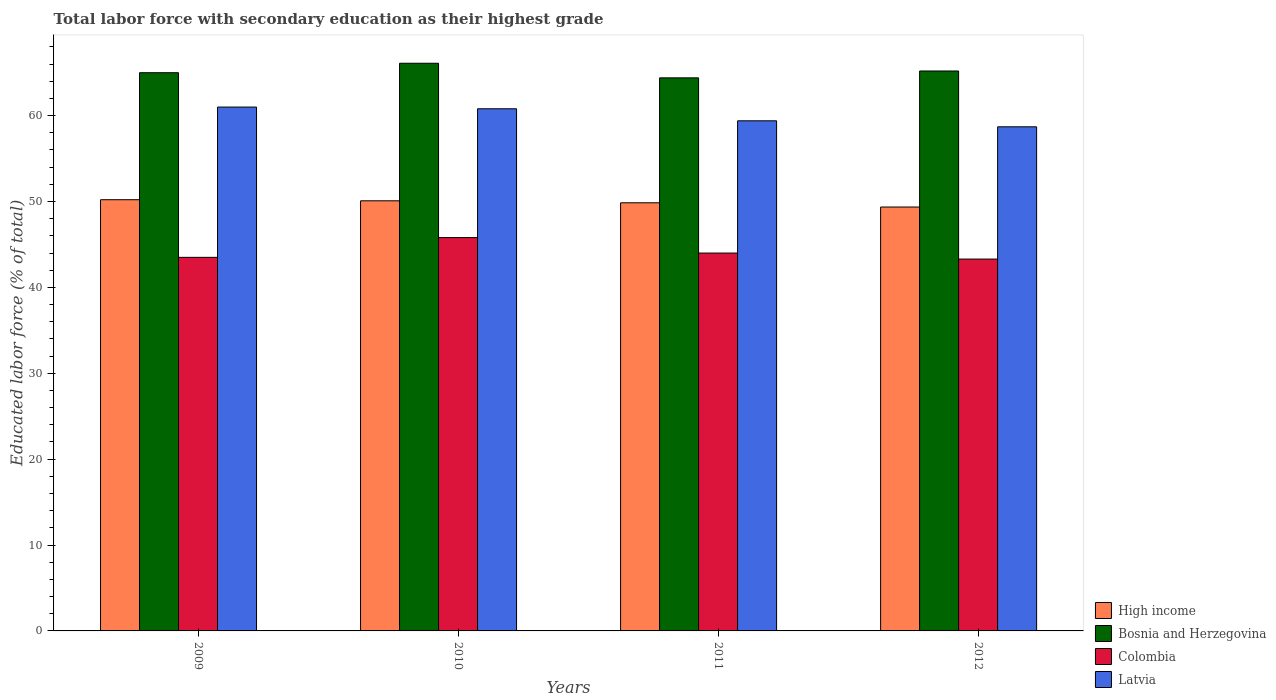How many different coloured bars are there?
Give a very brief answer. 4. How many groups of bars are there?
Your answer should be compact. 4. How many bars are there on the 4th tick from the left?
Provide a succinct answer. 4. How many bars are there on the 1st tick from the right?
Offer a terse response. 4. What is the label of the 1st group of bars from the left?
Keep it short and to the point. 2009. In how many cases, is the number of bars for a given year not equal to the number of legend labels?
Your response must be concise. 0. Across all years, what is the maximum percentage of total labor force with primary education in Colombia?
Make the answer very short. 45.8. Across all years, what is the minimum percentage of total labor force with primary education in High income?
Your answer should be very brief. 49.36. In which year was the percentage of total labor force with primary education in Latvia maximum?
Give a very brief answer. 2009. In which year was the percentage of total labor force with primary education in Latvia minimum?
Provide a succinct answer. 2012. What is the total percentage of total labor force with primary education in High income in the graph?
Give a very brief answer. 199.51. What is the difference between the percentage of total labor force with primary education in Bosnia and Herzegovina in 2009 and that in 2011?
Keep it short and to the point. 0.6. What is the difference between the percentage of total labor force with primary education in Colombia in 2011 and the percentage of total labor force with primary education in Bosnia and Herzegovina in 2009?
Your answer should be compact. -21. What is the average percentage of total labor force with primary education in Latvia per year?
Your response must be concise. 59.98. In the year 2011, what is the difference between the percentage of total labor force with primary education in Latvia and percentage of total labor force with primary education in Bosnia and Herzegovina?
Offer a terse response. -5. In how many years, is the percentage of total labor force with primary education in Bosnia and Herzegovina greater than 48 %?
Your answer should be very brief. 4. What is the ratio of the percentage of total labor force with primary education in Colombia in 2009 to that in 2010?
Your answer should be compact. 0.95. What is the difference between the highest and the second highest percentage of total labor force with primary education in Colombia?
Your answer should be very brief. 1.8. What is the difference between the highest and the lowest percentage of total labor force with primary education in Latvia?
Offer a terse response. 2.3. In how many years, is the percentage of total labor force with primary education in High income greater than the average percentage of total labor force with primary education in High income taken over all years?
Ensure brevity in your answer.  2. What does the 2nd bar from the left in 2009 represents?
Keep it short and to the point. Bosnia and Herzegovina. What does the 1st bar from the right in 2009 represents?
Your answer should be very brief. Latvia. How many bars are there?
Keep it short and to the point. 16. Are all the bars in the graph horizontal?
Your answer should be very brief. No. How many years are there in the graph?
Ensure brevity in your answer.  4. What is the difference between two consecutive major ticks on the Y-axis?
Offer a terse response. 10. Does the graph contain any zero values?
Give a very brief answer. No. Does the graph contain grids?
Your answer should be very brief. No. How many legend labels are there?
Make the answer very short. 4. What is the title of the graph?
Your answer should be very brief. Total labor force with secondary education as their highest grade. Does "Comoros" appear as one of the legend labels in the graph?
Your response must be concise. No. What is the label or title of the Y-axis?
Your answer should be compact. Educated labor force (% of total). What is the Educated labor force (% of total) in High income in 2009?
Your answer should be compact. 50.21. What is the Educated labor force (% of total) of Colombia in 2009?
Give a very brief answer. 43.5. What is the Educated labor force (% of total) of High income in 2010?
Provide a short and direct response. 50.08. What is the Educated labor force (% of total) in Bosnia and Herzegovina in 2010?
Your response must be concise. 66.1. What is the Educated labor force (% of total) in Colombia in 2010?
Your response must be concise. 45.8. What is the Educated labor force (% of total) of Latvia in 2010?
Your response must be concise. 60.8. What is the Educated labor force (% of total) of High income in 2011?
Provide a succinct answer. 49.85. What is the Educated labor force (% of total) in Bosnia and Herzegovina in 2011?
Give a very brief answer. 64.4. What is the Educated labor force (% of total) of Colombia in 2011?
Make the answer very short. 44. What is the Educated labor force (% of total) in Latvia in 2011?
Your response must be concise. 59.4. What is the Educated labor force (% of total) of High income in 2012?
Offer a terse response. 49.36. What is the Educated labor force (% of total) in Bosnia and Herzegovina in 2012?
Your response must be concise. 65.2. What is the Educated labor force (% of total) in Colombia in 2012?
Make the answer very short. 43.3. What is the Educated labor force (% of total) in Latvia in 2012?
Offer a terse response. 58.7. Across all years, what is the maximum Educated labor force (% of total) in High income?
Your answer should be very brief. 50.21. Across all years, what is the maximum Educated labor force (% of total) of Bosnia and Herzegovina?
Your answer should be compact. 66.1. Across all years, what is the maximum Educated labor force (% of total) in Colombia?
Give a very brief answer. 45.8. Across all years, what is the minimum Educated labor force (% of total) in High income?
Provide a short and direct response. 49.36. Across all years, what is the minimum Educated labor force (% of total) of Bosnia and Herzegovina?
Provide a succinct answer. 64.4. Across all years, what is the minimum Educated labor force (% of total) of Colombia?
Your answer should be very brief. 43.3. Across all years, what is the minimum Educated labor force (% of total) of Latvia?
Provide a succinct answer. 58.7. What is the total Educated labor force (% of total) of High income in the graph?
Your response must be concise. 199.51. What is the total Educated labor force (% of total) of Bosnia and Herzegovina in the graph?
Offer a terse response. 260.7. What is the total Educated labor force (% of total) in Colombia in the graph?
Your answer should be compact. 176.6. What is the total Educated labor force (% of total) of Latvia in the graph?
Offer a terse response. 239.9. What is the difference between the Educated labor force (% of total) of High income in 2009 and that in 2010?
Give a very brief answer. 0.13. What is the difference between the Educated labor force (% of total) in Bosnia and Herzegovina in 2009 and that in 2010?
Ensure brevity in your answer.  -1.1. What is the difference between the Educated labor force (% of total) in Latvia in 2009 and that in 2010?
Make the answer very short. 0.2. What is the difference between the Educated labor force (% of total) of High income in 2009 and that in 2011?
Your response must be concise. 0.36. What is the difference between the Educated labor force (% of total) in Colombia in 2009 and that in 2011?
Offer a very short reply. -0.5. What is the difference between the Educated labor force (% of total) of Latvia in 2009 and that in 2011?
Provide a short and direct response. 1.6. What is the difference between the Educated labor force (% of total) of High income in 2009 and that in 2012?
Offer a terse response. 0.85. What is the difference between the Educated labor force (% of total) of Colombia in 2009 and that in 2012?
Your answer should be compact. 0.2. What is the difference between the Educated labor force (% of total) in Latvia in 2009 and that in 2012?
Provide a short and direct response. 2.3. What is the difference between the Educated labor force (% of total) in High income in 2010 and that in 2011?
Give a very brief answer. 0.23. What is the difference between the Educated labor force (% of total) in Bosnia and Herzegovina in 2010 and that in 2011?
Your answer should be very brief. 1.7. What is the difference between the Educated labor force (% of total) in High income in 2010 and that in 2012?
Your answer should be compact. 0.72. What is the difference between the Educated labor force (% of total) of Bosnia and Herzegovina in 2010 and that in 2012?
Provide a succinct answer. 0.9. What is the difference between the Educated labor force (% of total) in Latvia in 2010 and that in 2012?
Offer a terse response. 2.1. What is the difference between the Educated labor force (% of total) of High income in 2011 and that in 2012?
Offer a very short reply. 0.49. What is the difference between the Educated labor force (% of total) in Bosnia and Herzegovina in 2011 and that in 2012?
Make the answer very short. -0.8. What is the difference between the Educated labor force (% of total) in Colombia in 2011 and that in 2012?
Offer a terse response. 0.7. What is the difference between the Educated labor force (% of total) of High income in 2009 and the Educated labor force (% of total) of Bosnia and Herzegovina in 2010?
Your answer should be very brief. -15.89. What is the difference between the Educated labor force (% of total) of High income in 2009 and the Educated labor force (% of total) of Colombia in 2010?
Offer a very short reply. 4.41. What is the difference between the Educated labor force (% of total) in High income in 2009 and the Educated labor force (% of total) in Latvia in 2010?
Offer a terse response. -10.59. What is the difference between the Educated labor force (% of total) in Bosnia and Herzegovina in 2009 and the Educated labor force (% of total) in Colombia in 2010?
Provide a succinct answer. 19.2. What is the difference between the Educated labor force (% of total) of Colombia in 2009 and the Educated labor force (% of total) of Latvia in 2010?
Your answer should be very brief. -17.3. What is the difference between the Educated labor force (% of total) in High income in 2009 and the Educated labor force (% of total) in Bosnia and Herzegovina in 2011?
Give a very brief answer. -14.19. What is the difference between the Educated labor force (% of total) of High income in 2009 and the Educated labor force (% of total) of Colombia in 2011?
Ensure brevity in your answer.  6.21. What is the difference between the Educated labor force (% of total) of High income in 2009 and the Educated labor force (% of total) of Latvia in 2011?
Your answer should be compact. -9.19. What is the difference between the Educated labor force (% of total) of Bosnia and Herzegovina in 2009 and the Educated labor force (% of total) of Colombia in 2011?
Offer a very short reply. 21. What is the difference between the Educated labor force (% of total) of Colombia in 2009 and the Educated labor force (% of total) of Latvia in 2011?
Offer a very short reply. -15.9. What is the difference between the Educated labor force (% of total) in High income in 2009 and the Educated labor force (% of total) in Bosnia and Herzegovina in 2012?
Make the answer very short. -14.99. What is the difference between the Educated labor force (% of total) in High income in 2009 and the Educated labor force (% of total) in Colombia in 2012?
Give a very brief answer. 6.91. What is the difference between the Educated labor force (% of total) in High income in 2009 and the Educated labor force (% of total) in Latvia in 2012?
Offer a very short reply. -8.49. What is the difference between the Educated labor force (% of total) of Bosnia and Herzegovina in 2009 and the Educated labor force (% of total) of Colombia in 2012?
Offer a very short reply. 21.7. What is the difference between the Educated labor force (% of total) in Bosnia and Herzegovina in 2009 and the Educated labor force (% of total) in Latvia in 2012?
Keep it short and to the point. 6.3. What is the difference between the Educated labor force (% of total) in Colombia in 2009 and the Educated labor force (% of total) in Latvia in 2012?
Your response must be concise. -15.2. What is the difference between the Educated labor force (% of total) of High income in 2010 and the Educated labor force (% of total) of Bosnia and Herzegovina in 2011?
Provide a short and direct response. -14.32. What is the difference between the Educated labor force (% of total) in High income in 2010 and the Educated labor force (% of total) in Colombia in 2011?
Offer a terse response. 6.08. What is the difference between the Educated labor force (% of total) in High income in 2010 and the Educated labor force (% of total) in Latvia in 2011?
Your response must be concise. -9.32. What is the difference between the Educated labor force (% of total) in Bosnia and Herzegovina in 2010 and the Educated labor force (% of total) in Colombia in 2011?
Make the answer very short. 22.1. What is the difference between the Educated labor force (% of total) in Bosnia and Herzegovina in 2010 and the Educated labor force (% of total) in Latvia in 2011?
Provide a succinct answer. 6.7. What is the difference between the Educated labor force (% of total) of Colombia in 2010 and the Educated labor force (% of total) of Latvia in 2011?
Offer a terse response. -13.6. What is the difference between the Educated labor force (% of total) of High income in 2010 and the Educated labor force (% of total) of Bosnia and Herzegovina in 2012?
Your answer should be very brief. -15.12. What is the difference between the Educated labor force (% of total) in High income in 2010 and the Educated labor force (% of total) in Colombia in 2012?
Your answer should be compact. 6.78. What is the difference between the Educated labor force (% of total) in High income in 2010 and the Educated labor force (% of total) in Latvia in 2012?
Your answer should be compact. -8.62. What is the difference between the Educated labor force (% of total) of Bosnia and Herzegovina in 2010 and the Educated labor force (% of total) of Colombia in 2012?
Keep it short and to the point. 22.8. What is the difference between the Educated labor force (% of total) of Colombia in 2010 and the Educated labor force (% of total) of Latvia in 2012?
Give a very brief answer. -12.9. What is the difference between the Educated labor force (% of total) of High income in 2011 and the Educated labor force (% of total) of Bosnia and Herzegovina in 2012?
Your answer should be very brief. -15.35. What is the difference between the Educated labor force (% of total) of High income in 2011 and the Educated labor force (% of total) of Colombia in 2012?
Offer a terse response. 6.55. What is the difference between the Educated labor force (% of total) in High income in 2011 and the Educated labor force (% of total) in Latvia in 2012?
Provide a succinct answer. -8.85. What is the difference between the Educated labor force (% of total) in Bosnia and Herzegovina in 2011 and the Educated labor force (% of total) in Colombia in 2012?
Your answer should be very brief. 21.1. What is the difference between the Educated labor force (% of total) in Bosnia and Herzegovina in 2011 and the Educated labor force (% of total) in Latvia in 2012?
Offer a terse response. 5.7. What is the difference between the Educated labor force (% of total) of Colombia in 2011 and the Educated labor force (% of total) of Latvia in 2012?
Keep it short and to the point. -14.7. What is the average Educated labor force (% of total) in High income per year?
Offer a terse response. 49.88. What is the average Educated labor force (% of total) of Bosnia and Herzegovina per year?
Your response must be concise. 65.17. What is the average Educated labor force (% of total) in Colombia per year?
Offer a terse response. 44.15. What is the average Educated labor force (% of total) in Latvia per year?
Keep it short and to the point. 59.98. In the year 2009, what is the difference between the Educated labor force (% of total) in High income and Educated labor force (% of total) in Bosnia and Herzegovina?
Your response must be concise. -14.79. In the year 2009, what is the difference between the Educated labor force (% of total) in High income and Educated labor force (% of total) in Colombia?
Offer a terse response. 6.71. In the year 2009, what is the difference between the Educated labor force (% of total) in High income and Educated labor force (% of total) in Latvia?
Ensure brevity in your answer.  -10.79. In the year 2009, what is the difference between the Educated labor force (% of total) of Bosnia and Herzegovina and Educated labor force (% of total) of Colombia?
Provide a succinct answer. 21.5. In the year 2009, what is the difference between the Educated labor force (% of total) of Colombia and Educated labor force (% of total) of Latvia?
Your answer should be very brief. -17.5. In the year 2010, what is the difference between the Educated labor force (% of total) of High income and Educated labor force (% of total) of Bosnia and Herzegovina?
Provide a short and direct response. -16.02. In the year 2010, what is the difference between the Educated labor force (% of total) of High income and Educated labor force (% of total) of Colombia?
Your response must be concise. 4.28. In the year 2010, what is the difference between the Educated labor force (% of total) in High income and Educated labor force (% of total) in Latvia?
Your answer should be very brief. -10.72. In the year 2010, what is the difference between the Educated labor force (% of total) in Bosnia and Herzegovina and Educated labor force (% of total) in Colombia?
Provide a succinct answer. 20.3. In the year 2010, what is the difference between the Educated labor force (% of total) in Colombia and Educated labor force (% of total) in Latvia?
Keep it short and to the point. -15. In the year 2011, what is the difference between the Educated labor force (% of total) of High income and Educated labor force (% of total) of Bosnia and Herzegovina?
Provide a short and direct response. -14.55. In the year 2011, what is the difference between the Educated labor force (% of total) of High income and Educated labor force (% of total) of Colombia?
Your answer should be very brief. 5.85. In the year 2011, what is the difference between the Educated labor force (% of total) in High income and Educated labor force (% of total) in Latvia?
Ensure brevity in your answer.  -9.55. In the year 2011, what is the difference between the Educated labor force (% of total) in Bosnia and Herzegovina and Educated labor force (% of total) in Colombia?
Your answer should be compact. 20.4. In the year 2011, what is the difference between the Educated labor force (% of total) of Bosnia and Herzegovina and Educated labor force (% of total) of Latvia?
Give a very brief answer. 5. In the year 2011, what is the difference between the Educated labor force (% of total) in Colombia and Educated labor force (% of total) in Latvia?
Ensure brevity in your answer.  -15.4. In the year 2012, what is the difference between the Educated labor force (% of total) of High income and Educated labor force (% of total) of Bosnia and Herzegovina?
Make the answer very short. -15.84. In the year 2012, what is the difference between the Educated labor force (% of total) in High income and Educated labor force (% of total) in Colombia?
Offer a terse response. 6.06. In the year 2012, what is the difference between the Educated labor force (% of total) in High income and Educated labor force (% of total) in Latvia?
Offer a very short reply. -9.34. In the year 2012, what is the difference between the Educated labor force (% of total) of Bosnia and Herzegovina and Educated labor force (% of total) of Colombia?
Keep it short and to the point. 21.9. In the year 2012, what is the difference between the Educated labor force (% of total) in Colombia and Educated labor force (% of total) in Latvia?
Offer a very short reply. -15.4. What is the ratio of the Educated labor force (% of total) of High income in 2009 to that in 2010?
Keep it short and to the point. 1. What is the ratio of the Educated labor force (% of total) in Bosnia and Herzegovina in 2009 to that in 2010?
Your answer should be very brief. 0.98. What is the ratio of the Educated labor force (% of total) of Colombia in 2009 to that in 2010?
Make the answer very short. 0.95. What is the ratio of the Educated labor force (% of total) in High income in 2009 to that in 2011?
Your answer should be compact. 1.01. What is the ratio of the Educated labor force (% of total) in Bosnia and Herzegovina in 2009 to that in 2011?
Your response must be concise. 1.01. What is the ratio of the Educated labor force (% of total) in Colombia in 2009 to that in 2011?
Your answer should be compact. 0.99. What is the ratio of the Educated labor force (% of total) of Latvia in 2009 to that in 2011?
Provide a short and direct response. 1.03. What is the ratio of the Educated labor force (% of total) in High income in 2009 to that in 2012?
Offer a terse response. 1.02. What is the ratio of the Educated labor force (% of total) in Bosnia and Herzegovina in 2009 to that in 2012?
Your answer should be very brief. 1. What is the ratio of the Educated labor force (% of total) in Colombia in 2009 to that in 2012?
Offer a terse response. 1. What is the ratio of the Educated labor force (% of total) of Latvia in 2009 to that in 2012?
Ensure brevity in your answer.  1.04. What is the ratio of the Educated labor force (% of total) in Bosnia and Herzegovina in 2010 to that in 2011?
Your response must be concise. 1.03. What is the ratio of the Educated labor force (% of total) in Colombia in 2010 to that in 2011?
Provide a short and direct response. 1.04. What is the ratio of the Educated labor force (% of total) in Latvia in 2010 to that in 2011?
Your answer should be very brief. 1.02. What is the ratio of the Educated labor force (% of total) in High income in 2010 to that in 2012?
Ensure brevity in your answer.  1.01. What is the ratio of the Educated labor force (% of total) of Bosnia and Herzegovina in 2010 to that in 2012?
Provide a succinct answer. 1.01. What is the ratio of the Educated labor force (% of total) of Colombia in 2010 to that in 2012?
Provide a short and direct response. 1.06. What is the ratio of the Educated labor force (% of total) in Latvia in 2010 to that in 2012?
Offer a very short reply. 1.04. What is the ratio of the Educated labor force (% of total) of High income in 2011 to that in 2012?
Make the answer very short. 1.01. What is the ratio of the Educated labor force (% of total) in Bosnia and Herzegovina in 2011 to that in 2012?
Ensure brevity in your answer.  0.99. What is the ratio of the Educated labor force (% of total) of Colombia in 2011 to that in 2012?
Give a very brief answer. 1.02. What is the ratio of the Educated labor force (% of total) in Latvia in 2011 to that in 2012?
Make the answer very short. 1.01. What is the difference between the highest and the second highest Educated labor force (% of total) in High income?
Your answer should be very brief. 0.13. What is the difference between the highest and the second highest Educated labor force (% of total) of Bosnia and Herzegovina?
Keep it short and to the point. 0.9. What is the difference between the highest and the second highest Educated labor force (% of total) in Colombia?
Give a very brief answer. 1.8. What is the difference between the highest and the lowest Educated labor force (% of total) of High income?
Your response must be concise. 0.85. What is the difference between the highest and the lowest Educated labor force (% of total) of Bosnia and Herzegovina?
Your answer should be compact. 1.7. What is the difference between the highest and the lowest Educated labor force (% of total) in Colombia?
Provide a succinct answer. 2.5. 